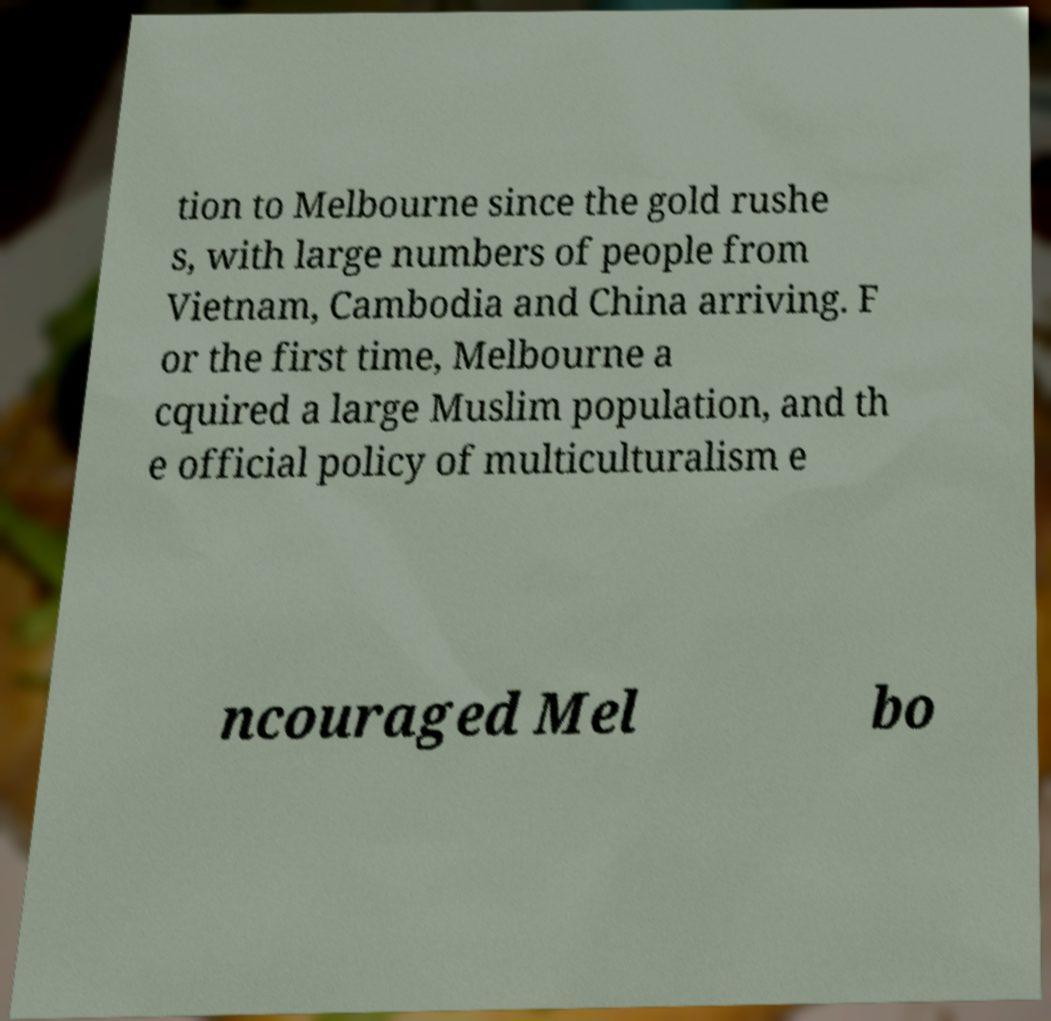Please identify and transcribe the text found in this image. tion to Melbourne since the gold rushe s, with large numbers of people from Vietnam, Cambodia and China arriving. F or the first time, Melbourne a cquired a large Muslim population, and th e official policy of multiculturalism e ncouraged Mel bo 